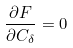<formula> <loc_0><loc_0><loc_500><loc_500>\frac { \partial F } { \partial C _ { \delta } } = 0</formula> 